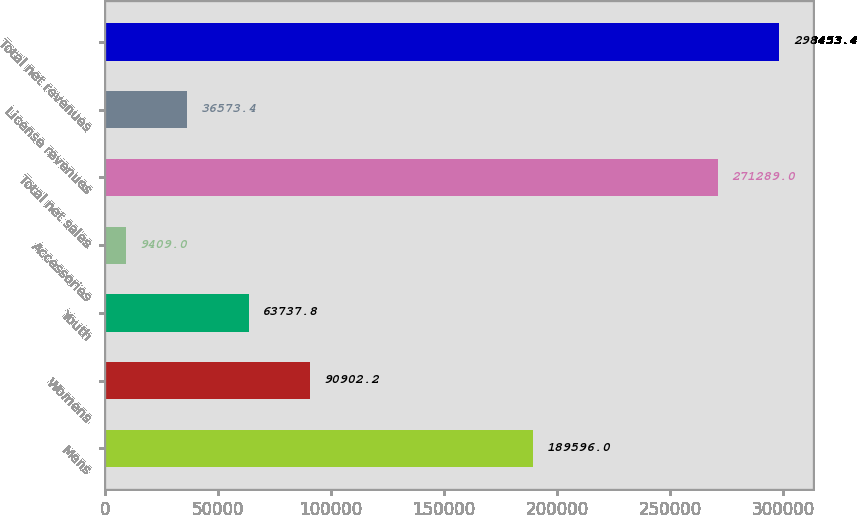<chart> <loc_0><loc_0><loc_500><loc_500><bar_chart><fcel>Mens<fcel>Womens<fcel>Youth<fcel>Accessories<fcel>Total net sales<fcel>License revenues<fcel>Total net revenues<nl><fcel>189596<fcel>90902.2<fcel>63737.8<fcel>9409<fcel>271289<fcel>36573.4<fcel>298453<nl></chart> 